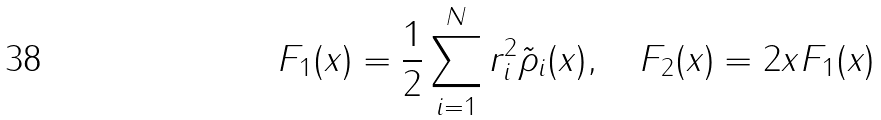Convert formula to latex. <formula><loc_0><loc_0><loc_500><loc_500>F _ { 1 } ( x ) = \frac { 1 } { 2 } \sum _ { i = 1 } ^ { N } r _ { i } ^ { 2 } \tilde { \rho } _ { i } ( x ) , \quad F _ { 2 } ( x ) = 2 x F _ { 1 } ( x )</formula> 